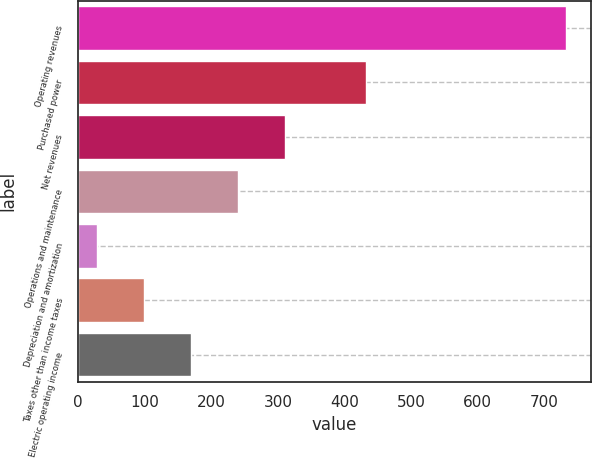<chart> <loc_0><loc_0><loc_500><loc_500><bar_chart><fcel>Operating revenues<fcel>Purchased power<fcel>Net revenues<fcel>Operations and maintenance<fcel>Depreciation and amortization<fcel>Taxes other than income taxes<fcel>Electric operating income<nl><fcel>733<fcel>433<fcel>310.6<fcel>240.2<fcel>29<fcel>99.4<fcel>169.8<nl></chart> 